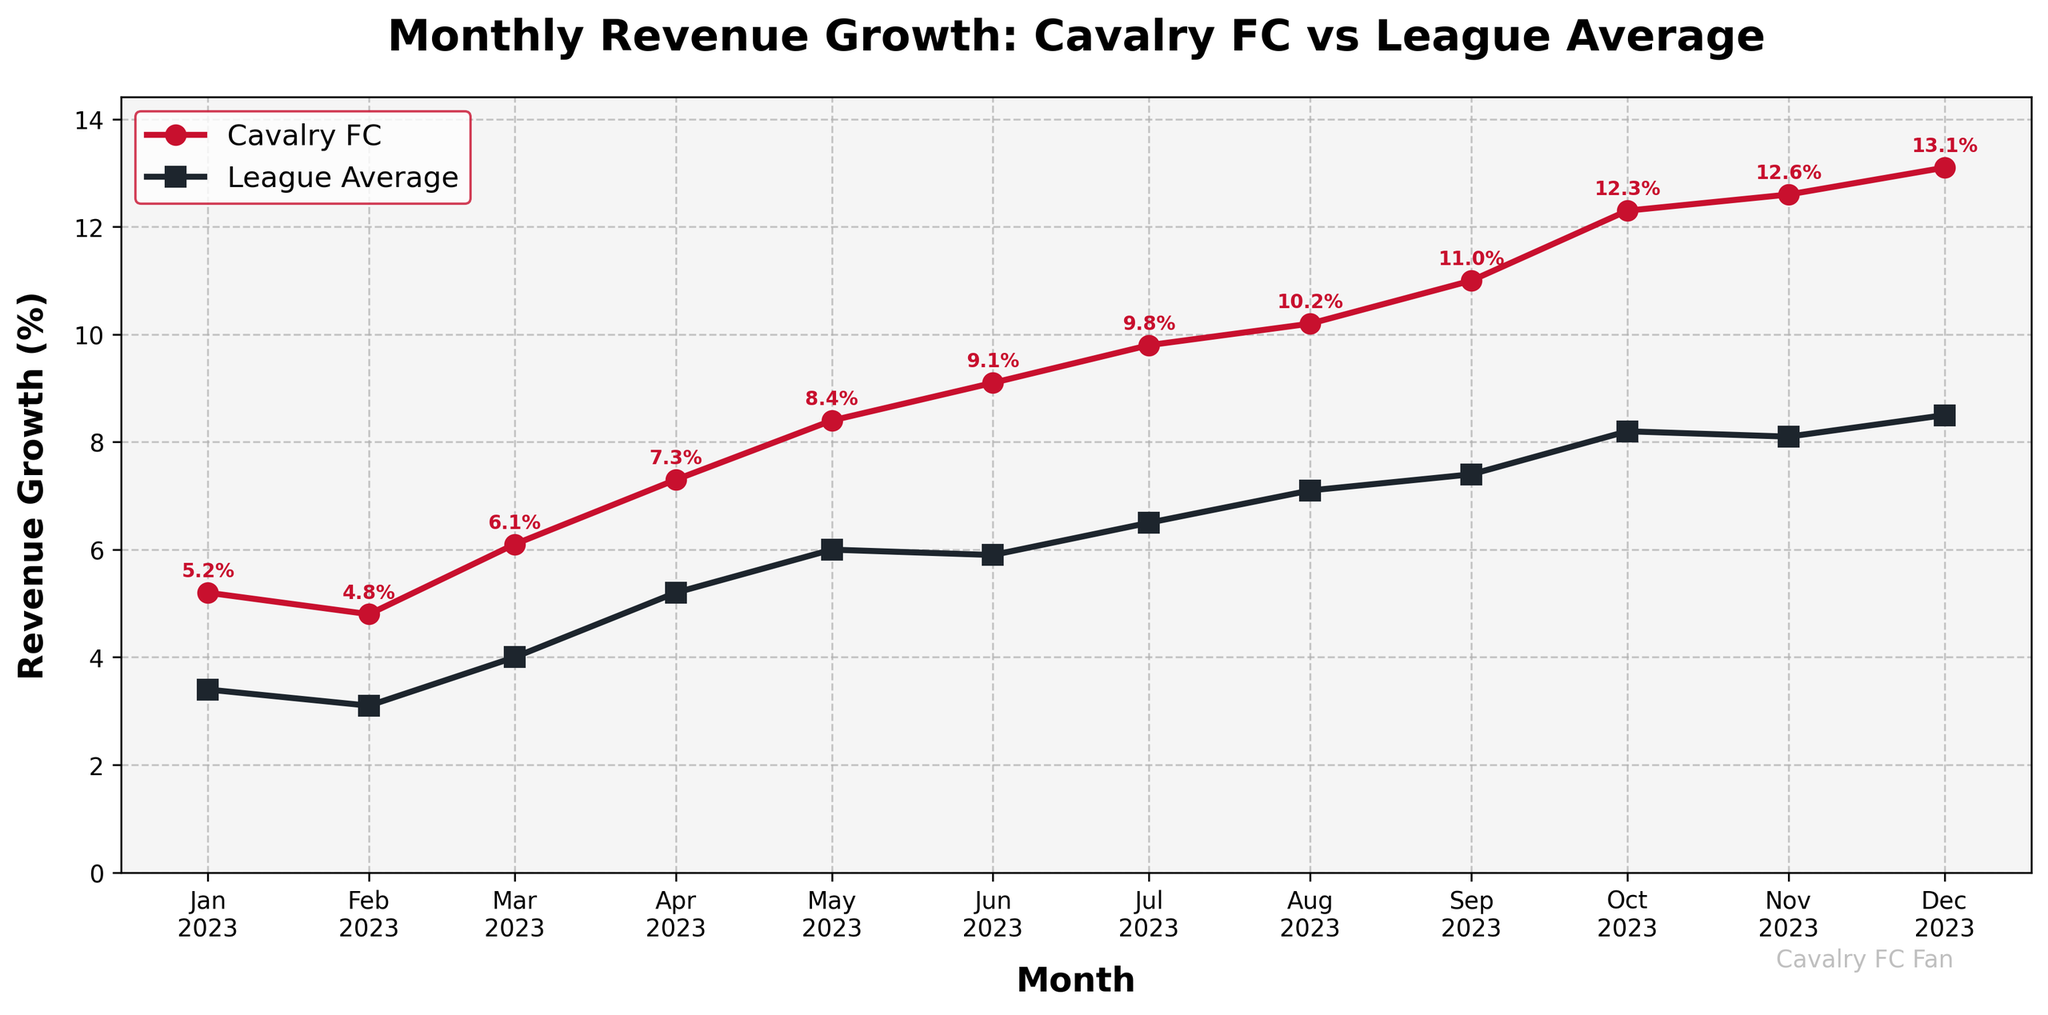What is the title of the plot? The title of the plot is located at the top and describes what the plot represents.
Answer: Monthly Revenue Growth: Cavalry FC vs League Average Which team has consistently higher revenue growth in the plotted months? We can look at the plot and compare the two lines representing Cavalry FC's and the league average's revenue growth. The red line, representing Cavalry FC, is consistently above the dark gray line of the league average.
Answer: Cavalry FC What was Cavalry FC's highest monthly revenue growth percentage and in which month did it occur? We need to identify the highest point on the red line and read both the value and the corresponding month. The highest point is at 13.1% in December 2023.
Answer: 13.1% in December 2023 In which month did the smallest difference between Cavalry FC's and the league average's revenue growth occur? By examining the distance between the two lines for each month, the smallest gap is observed in November 2023 where Cavalry FC and the league average really come close.
Answer: November 2023 How many months did Cavalry FC's revenue growth exceed 10%? We check the red line to see above which points it crosses the 10% mark which are August, September, October, November, and December. This results in a total of five months.
Answer: 5 What is the average revenue growth of Cavalry FC over the plotted months? To find the average, sum up all monthly growth values for Cavalry FC and divide by the number of months. (5.2 + 4.8 + 6.1 + 7.3 + 8.4 + 9.1 + 9.8 + 10.2 + 11.0 + 12.3 + 12.6 + 13.1) / 12 = 8.73
Answer: 8.73% Which month sees the largest increase in revenue growth for Cavalry FC compared to the previous month? We determine the monthly differences for Cavalry FC and identify the largest one. April sees a jump from 6.1% to 7.3%, an increase of 1.2%.
Answer: April 2023 By how much does the league average revenue growth increase from January to December? We calculate the difference between the league average revenues in December and January. 8.5 - 3.4 = 5.1%
Answer: 5.1% What was the revenue growth percentage difference between Cavalry FC and the league average in October 2023? Identify the values for October for both Cavalry FC and the league average and compute the difference. (12.3 - 8.2 = 4.1%)
Answer: 4.1% Which month showed the highest revenue growth for the league average? Identifying the highest point on the dark gray line, it can be inferred that December 2023 holds the peak at 8.5%.
Answer: December 2023 